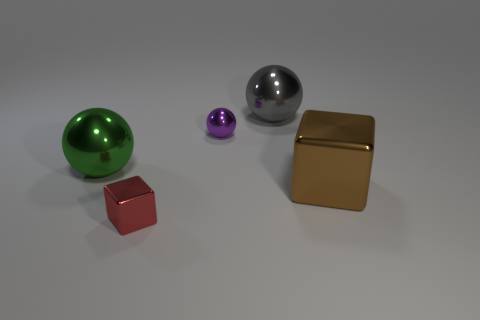There is a tiny thing behind the large thing left of the red thing; what color is it? purple 